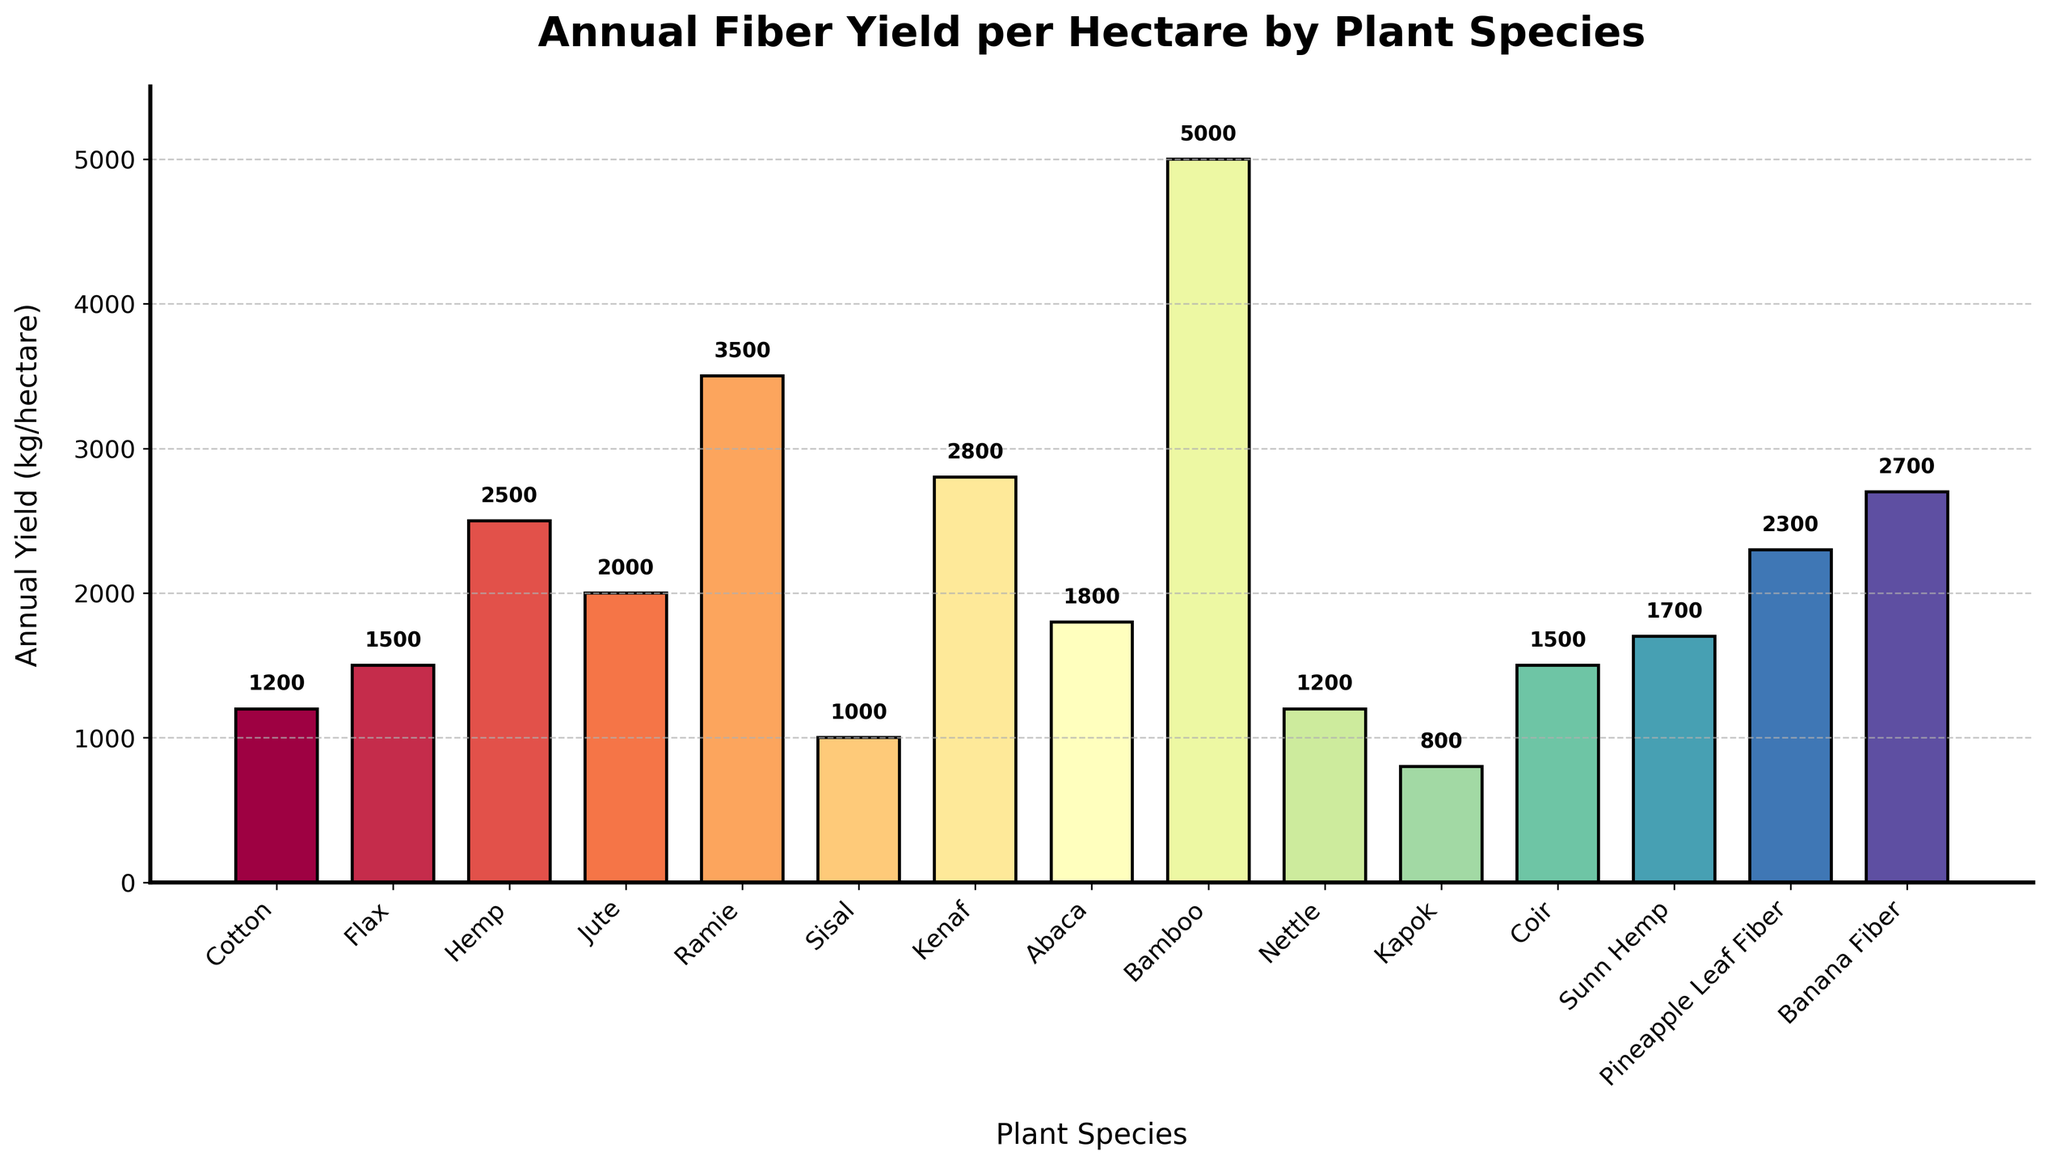How many plant species have an annual yield greater than 2000 kg/hectare? Identify the species with yields over 2000 kg/hectare: Hemp (2500 kg/hectare), Jute (2000 kg/hectare exactly), Ramie (3500 kg/hectare), Kenaf (2800 kg/hectare), Bamboo (5000 kg/hectare), Pineapple Leaf Fiber (2300 kg/hectare), Banana Fiber (2700 kg/hectare). Exclude Jute as it is exactly 2000, not greater. This gives us Hemp, Ramie, Kenaf, Bamboo, Pineapple Leaf Fiber, and Banana Fiber, totaling 6 species.
Answer: 6 Which plant species has the highest annual yield? Look for the tallest bar in the bar chart. Bamboo has the highest bar representing an annual yield of 5000 kg/hectare.
Answer: Bamboo What is the combined annual yield of Cotton and Nettle? Locate the bars for Cotton and Nettle. Cotton has an annual yield of 1200 kg/hectare and Nettle also 1200 kg/hectare. Sum these yields: 1200 + 1200 = 2400 kg/hectare.
Answer: 2400 Is Ramie’s annual yield higher than Jute’s annual yield? Compare the heights of the bars for Ramie and Jute. Ramie’s yield is 3500 kg/hectare and Jute’s yield is 2000 kg/hectare. Since 3500 is greater than 2000, the answer is yes.
Answer: Yes What is the difference in annual yield between the plant with the highest yield and the plant with the lowest yield? Locate the highest yield (Bamboo, 5000 kg/hectare) and the lowest yield (Kapok, 800 kg/hectare). The difference is 5000 - 800 = 4200 kg/hectare.
Answer: 4200 Which two plant species have equal annual yields? Identify bars with equal heights. Both Cotton and Nettle have an annual yield of 1200 kg/hectare, and both Flax and Coir have 1500 kg/hectare.
Answer: Cotton and Nettle, Flax and Coir Rank the top three plant species by highest annual yield. Identify the three tallest bars. First is Bamboo (5000 kg/hectare), second is Ramie (3500 kg/hectare), and third is Kenaf (2800 kg/hectare).
Answer: Bamboo, Ramie, Kenaf What is the average annual yield of all plant species shown? Add all annual yields: 1200 + 1500 + 2500 + 2000 + 3500 + 1000 + 2800 + 1800 + 5000 + 1200 + 800 + 1500 + 1700 + 2300 + 2700 = 34100. Count the species: 15. Divide total yield by number of species: 34100 / 15 ≈ 2273.33 kg/hectare.
Answer: 2273.33 Which plant species yields more: Kenaf or Pineapple Leaf Fiber? Locate the bars for Kenaf (2800 kg/hectare) and Pineapple Leaf Fiber (2300 kg/hectare). Kenaf has a higher yield than Pineapple Leaf Fiber.
Answer: Kenaf 